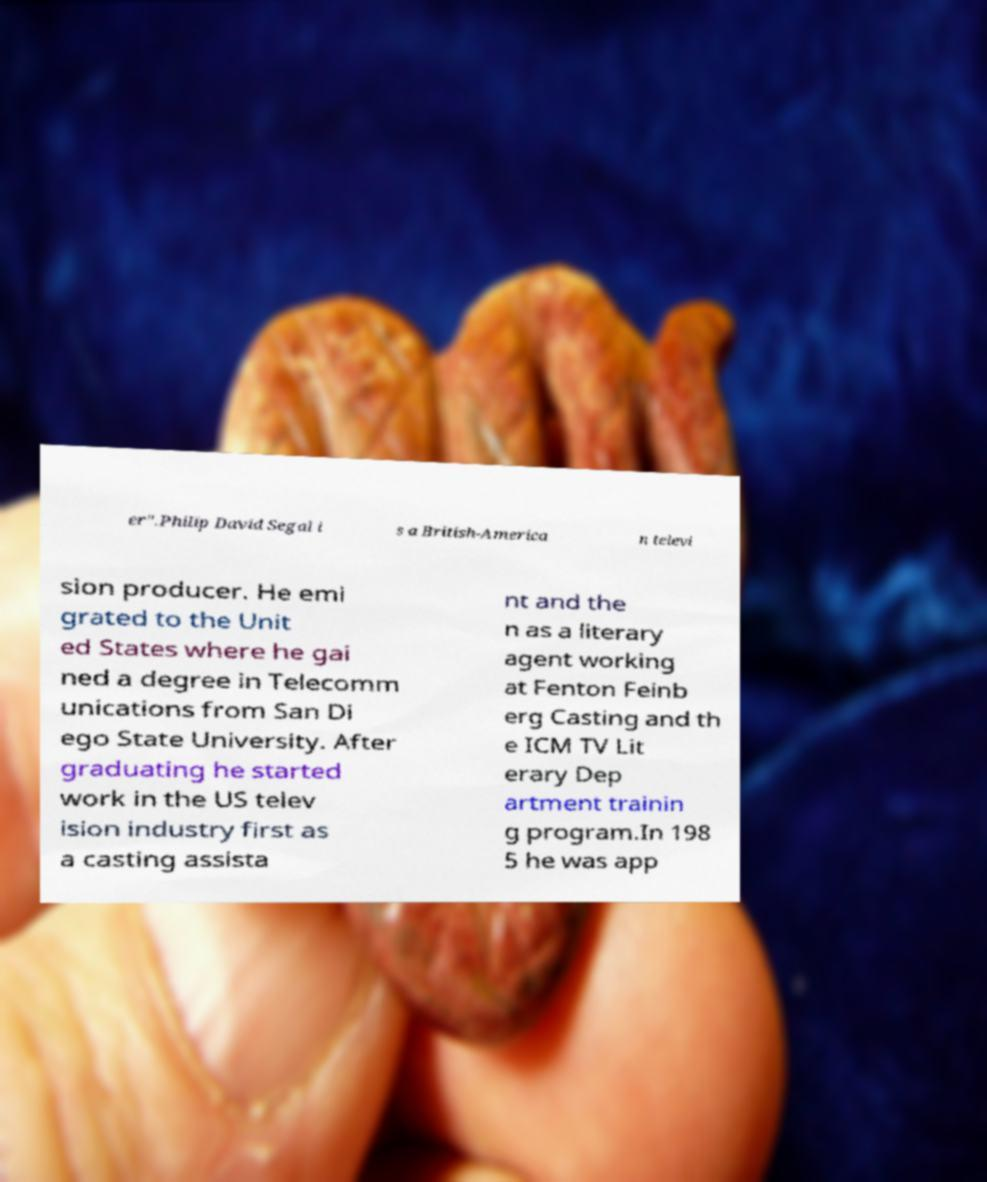Can you accurately transcribe the text from the provided image for me? er".Philip David Segal i s a British-America n televi sion producer. He emi grated to the Unit ed States where he gai ned a degree in Telecomm unications from San Di ego State University. After graduating he started work in the US telev ision industry first as a casting assista nt and the n as a literary agent working at Fenton Feinb erg Casting and th e ICM TV Lit erary Dep artment trainin g program.In 198 5 he was app 